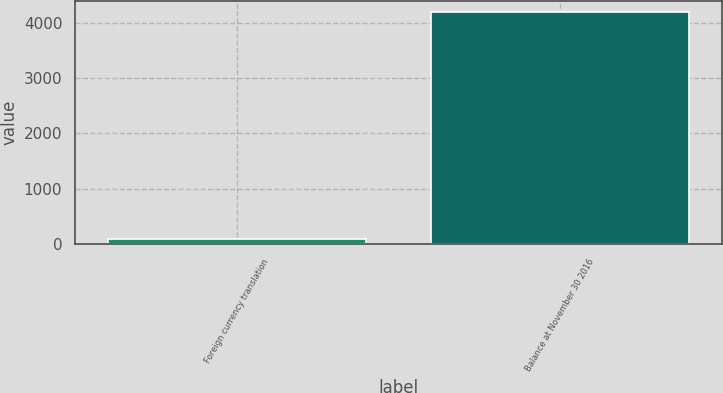Convert chart to OTSL. <chart><loc_0><loc_0><loc_500><loc_500><bar_chart><fcel>Foreign currency translation<fcel>Balance at November 30 2016<nl><fcel>95.5<fcel>4185.5<nl></chart> 